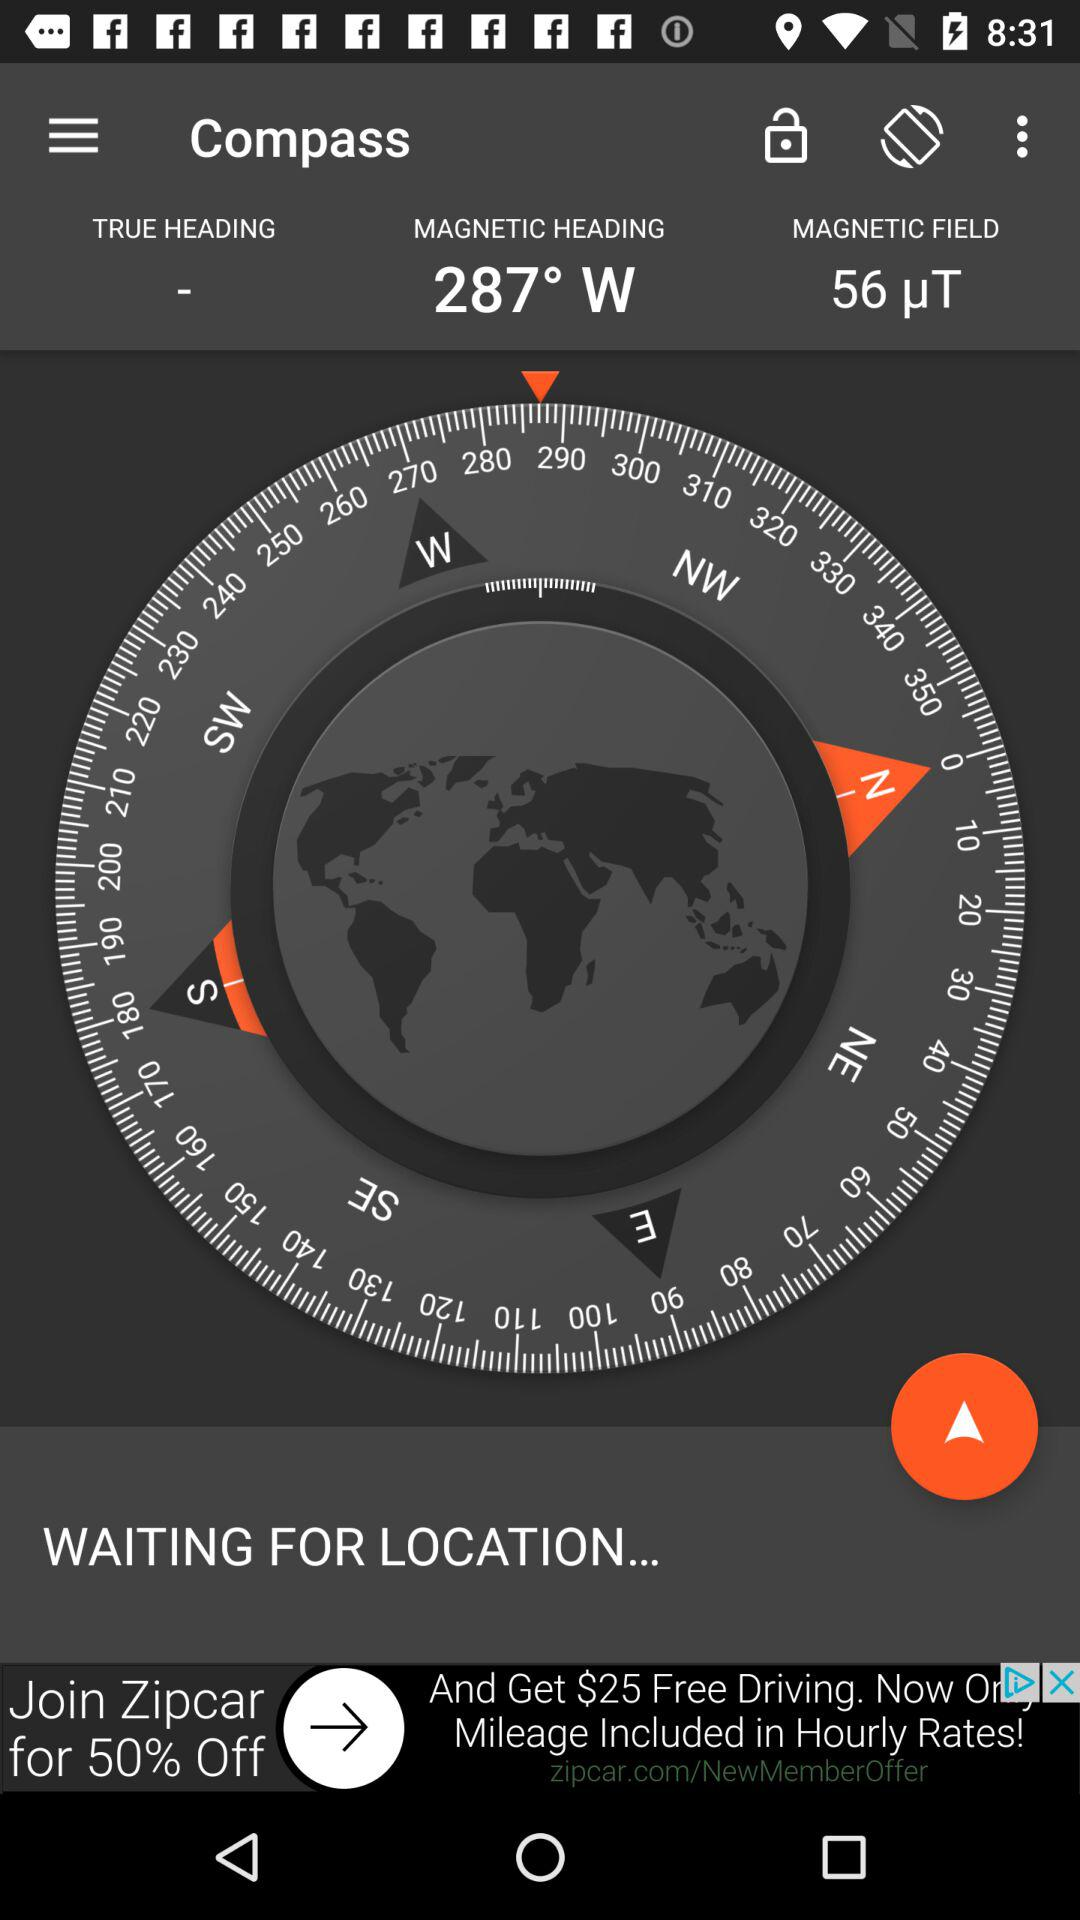What is the magnetic field? The magnetic field is 56 µT. 